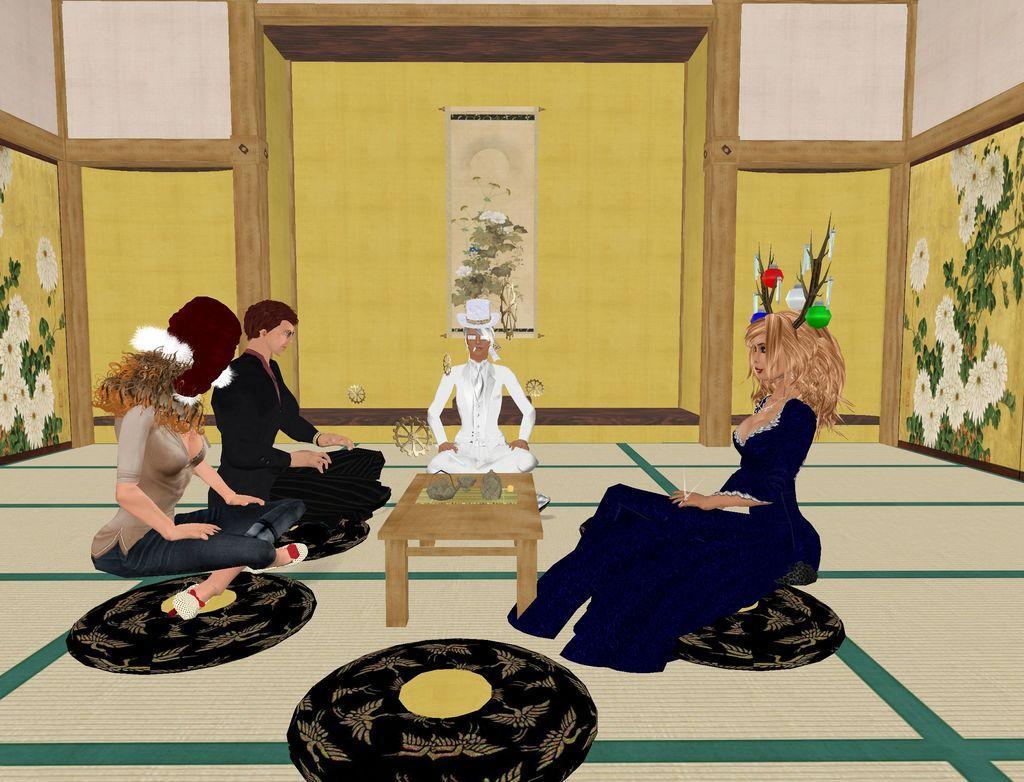Could you give a brief overview of what you see in this image? In the foreground of this animated image, there are people sitting on the floor mat around a table on which there are few objects. In the background, there is wall and a frame. 